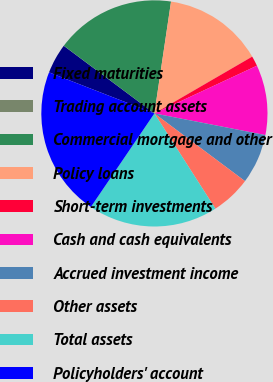Convert chart to OTSL. <chart><loc_0><loc_0><loc_500><loc_500><pie_chart><fcel>Fixed maturities<fcel>Trading account assets<fcel>Commercial mortgage and other<fcel>Policy loans<fcel>Short-term investments<fcel>Cash and cash equivalents<fcel>Accrued investment income<fcel>Other assets<fcel>Total assets<fcel>Policyholders' account<nl><fcel>4.29%<fcel>0.01%<fcel>17.14%<fcel>14.28%<fcel>1.44%<fcel>10.0%<fcel>7.15%<fcel>5.72%<fcel>18.56%<fcel>21.42%<nl></chart> 